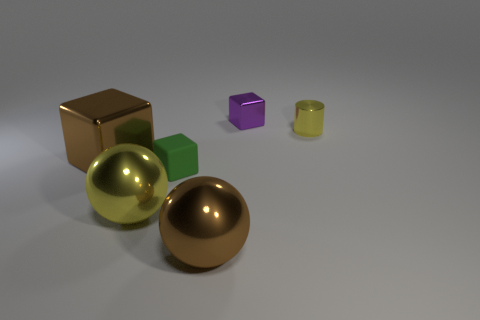Is there a sense of depth or dimension in the image? Yes, the arrangement and varying sizes of the objects create a sense of depth. The shadows and the lighting also contribute to the image's three-dimensional appearance. 